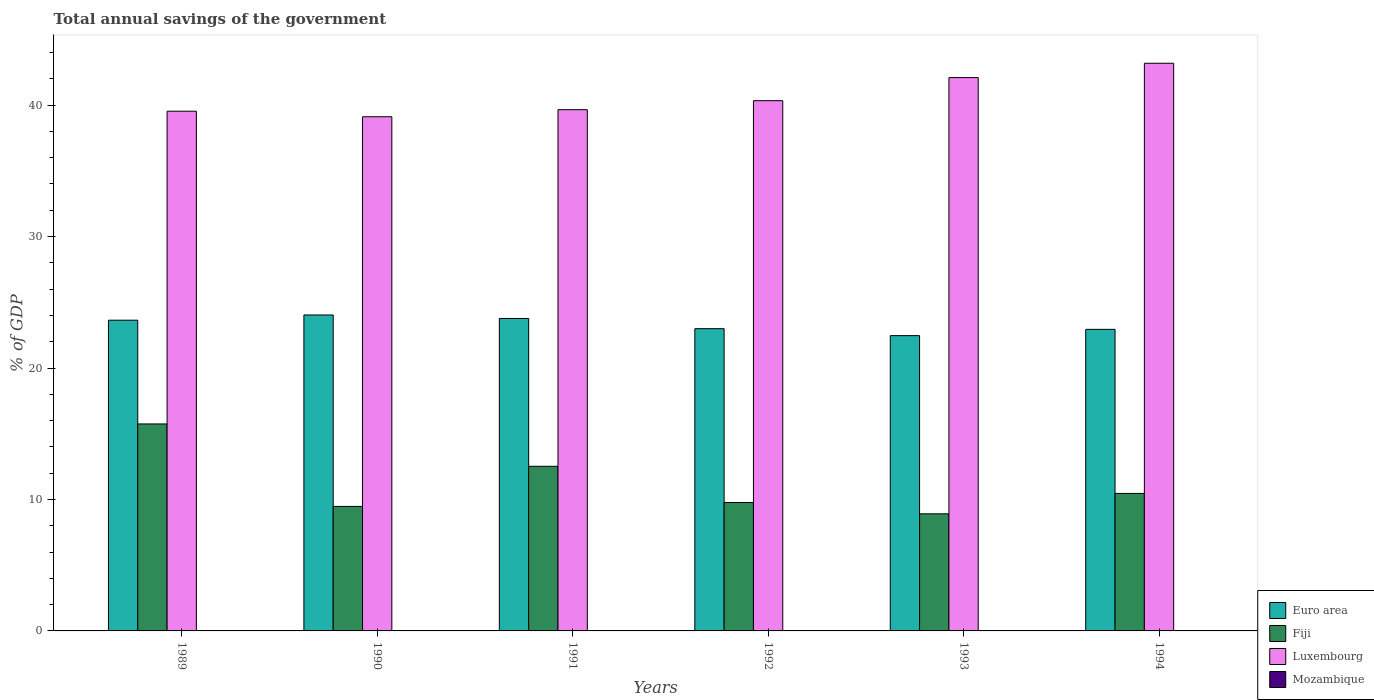Are the number of bars per tick equal to the number of legend labels?
Your answer should be compact. No. Are the number of bars on each tick of the X-axis equal?
Your answer should be compact. Yes. How many bars are there on the 2nd tick from the left?
Give a very brief answer. 3. What is the total annual savings of the government in Euro area in 1990?
Your answer should be very brief. 24.03. Across all years, what is the maximum total annual savings of the government in Euro area?
Your response must be concise. 24.03. Across all years, what is the minimum total annual savings of the government in Euro area?
Offer a very short reply. 22.46. What is the total total annual savings of the government in Euro area in the graph?
Your answer should be compact. 139.83. What is the difference between the total annual savings of the government in Luxembourg in 1993 and that in 1994?
Provide a short and direct response. -1.09. What is the difference between the total annual savings of the government in Fiji in 1992 and the total annual savings of the government in Euro area in 1993?
Provide a succinct answer. -12.69. What is the average total annual savings of the government in Euro area per year?
Keep it short and to the point. 23.31. In the year 1991, what is the difference between the total annual savings of the government in Euro area and total annual savings of the government in Fiji?
Give a very brief answer. 11.25. What is the ratio of the total annual savings of the government in Fiji in 1990 to that in 1991?
Your answer should be very brief. 0.76. Is the total annual savings of the government in Luxembourg in 1989 less than that in 1994?
Your answer should be compact. Yes. Is the difference between the total annual savings of the government in Euro area in 1989 and 1991 greater than the difference between the total annual savings of the government in Fiji in 1989 and 1991?
Make the answer very short. No. What is the difference between the highest and the second highest total annual savings of the government in Euro area?
Make the answer very short. 0.27. What is the difference between the highest and the lowest total annual savings of the government in Euro area?
Offer a terse response. 1.57. In how many years, is the total annual savings of the government in Euro area greater than the average total annual savings of the government in Euro area taken over all years?
Keep it short and to the point. 3. Is it the case that in every year, the sum of the total annual savings of the government in Euro area and total annual savings of the government in Mozambique is greater than the sum of total annual savings of the government in Luxembourg and total annual savings of the government in Fiji?
Keep it short and to the point. No. Is it the case that in every year, the sum of the total annual savings of the government in Fiji and total annual savings of the government in Euro area is greater than the total annual savings of the government in Luxembourg?
Your response must be concise. No. Are all the bars in the graph horizontal?
Offer a terse response. No. How many years are there in the graph?
Offer a terse response. 6. Does the graph contain grids?
Offer a terse response. No. How many legend labels are there?
Provide a succinct answer. 4. What is the title of the graph?
Your answer should be very brief. Total annual savings of the government. Does "St. Kitts and Nevis" appear as one of the legend labels in the graph?
Make the answer very short. No. What is the label or title of the Y-axis?
Keep it short and to the point. % of GDP. What is the % of GDP of Euro area in 1989?
Make the answer very short. 23.64. What is the % of GDP in Fiji in 1989?
Offer a terse response. 15.74. What is the % of GDP in Luxembourg in 1989?
Your response must be concise. 39.53. What is the % of GDP in Mozambique in 1989?
Your response must be concise. 0. What is the % of GDP of Euro area in 1990?
Provide a short and direct response. 24.03. What is the % of GDP in Fiji in 1990?
Provide a succinct answer. 9.47. What is the % of GDP of Luxembourg in 1990?
Give a very brief answer. 39.11. What is the % of GDP of Euro area in 1991?
Your answer should be very brief. 23.77. What is the % of GDP in Fiji in 1991?
Provide a short and direct response. 12.52. What is the % of GDP of Luxembourg in 1991?
Your answer should be compact. 39.65. What is the % of GDP in Euro area in 1992?
Offer a very short reply. 22.99. What is the % of GDP of Fiji in 1992?
Your answer should be compact. 9.77. What is the % of GDP of Luxembourg in 1992?
Provide a succinct answer. 40.33. What is the % of GDP of Mozambique in 1992?
Your answer should be very brief. 0. What is the % of GDP of Euro area in 1993?
Your answer should be very brief. 22.46. What is the % of GDP of Fiji in 1993?
Your response must be concise. 8.91. What is the % of GDP in Luxembourg in 1993?
Make the answer very short. 42.09. What is the % of GDP of Euro area in 1994?
Offer a very short reply. 22.94. What is the % of GDP of Fiji in 1994?
Offer a very short reply. 10.46. What is the % of GDP in Luxembourg in 1994?
Your answer should be compact. 43.18. Across all years, what is the maximum % of GDP of Euro area?
Provide a succinct answer. 24.03. Across all years, what is the maximum % of GDP in Fiji?
Keep it short and to the point. 15.74. Across all years, what is the maximum % of GDP in Luxembourg?
Your answer should be compact. 43.18. Across all years, what is the minimum % of GDP in Euro area?
Give a very brief answer. 22.46. Across all years, what is the minimum % of GDP in Fiji?
Your response must be concise. 8.91. Across all years, what is the minimum % of GDP in Luxembourg?
Offer a very short reply. 39.11. What is the total % of GDP in Euro area in the graph?
Make the answer very short. 139.83. What is the total % of GDP of Fiji in the graph?
Give a very brief answer. 66.87. What is the total % of GDP in Luxembourg in the graph?
Ensure brevity in your answer.  243.91. What is the total % of GDP in Mozambique in the graph?
Make the answer very short. 0. What is the difference between the % of GDP of Euro area in 1989 and that in 1990?
Ensure brevity in your answer.  -0.4. What is the difference between the % of GDP in Fiji in 1989 and that in 1990?
Your answer should be very brief. 6.27. What is the difference between the % of GDP in Luxembourg in 1989 and that in 1990?
Give a very brief answer. 0.42. What is the difference between the % of GDP of Euro area in 1989 and that in 1991?
Give a very brief answer. -0.13. What is the difference between the % of GDP of Fiji in 1989 and that in 1991?
Offer a terse response. 3.22. What is the difference between the % of GDP in Luxembourg in 1989 and that in 1991?
Keep it short and to the point. -0.12. What is the difference between the % of GDP in Euro area in 1989 and that in 1992?
Offer a terse response. 0.65. What is the difference between the % of GDP in Fiji in 1989 and that in 1992?
Ensure brevity in your answer.  5.98. What is the difference between the % of GDP of Luxembourg in 1989 and that in 1992?
Ensure brevity in your answer.  -0.8. What is the difference between the % of GDP in Euro area in 1989 and that in 1993?
Keep it short and to the point. 1.17. What is the difference between the % of GDP of Fiji in 1989 and that in 1993?
Your response must be concise. 6.84. What is the difference between the % of GDP in Luxembourg in 1989 and that in 1993?
Offer a terse response. -2.56. What is the difference between the % of GDP of Euro area in 1989 and that in 1994?
Ensure brevity in your answer.  0.7. What is the difference between the % of GDP of Fiji in 1989 and that in 1994?
Your answer should be compact. 5.29. What is the difference between the % of GDP of Luxembourg in 1989 and that in 1994?
Keep it short and to the point. -3.65. What is the difference between the % of GDP of Euro area in 1990 and that in 1991?
Your answer should be compact. 0.27. What is the difference between the % of GDP in Fiji in 1990 and that in 1991?
Ensure brevity in your answer.  -3.05. What is the difference between the % of GDP of Luxembourg in 1990 and that in 1991?
Make the answer very short. -0.54. What is the difference between the % of GDP of Euro area in 1990 and that in 1992?
Offer a terse response. 1.04. What is the difference between the % of GDP in Fiji in 1990 and that in 1992?
Keep it short and to the point. -0.3. What is the difference between the % of GDP in Luxembourg in 1990 and that in 1992?
Your answer should be compact. -1.22. What is the difference between the % of GDP in Euro area in 1990 and that in 1993?
Offer a very short reply. 1.57. What is the difference between the % of GDP in Fiji in 1990 and that in 1993?
Your answer should be very brief. 0.56. What is the difference between the % of GDP in Luxembourg in 1990 and that in 1993?
Provide a succinct answer. -2.98. What is the difference between the % of GDP of Euro area in 1990 and that in 1994?
Keep it short and to the point. 1.09. What is the difference between the % of GDP of Fiji in 1990 and that in 1994?
Offer a terse response. -0.99. What is the difference between the % of GDP of Luxembourg in 1990 and that in 1994?
Your answer should be compact. -4.07. What is the difference between the % of GDP in Euro area in 1991 and that in 1992?
Ensure brevity in your answer.  0.78. What is the difference between the % of GDP of Fiji in 1991 and that in 1992?
Ensure brevity in your answer.  2.75. What is the difference between the % of GDP in Luxembourg in 1991 and that in 1992?
Offer a very short reply. -0.68. What is the difference between the % of GDP of Euro area in 1991 and that in 1993?
Your answer should be compact. 1.31. What is the difference between the % of GDP in Fiji in 1991 and that in 1993?
Your answer should be compact. 3.61. What is the difference between the % of GDP of Luxembourg in 1991 and that in 1993?
Provide a short and direct response. -2.44. What is the difference between the % of GDP of Euro area in 1991 and that in 1994?
Offer a very short reply. 0.83. What is the difference between the % of GDP of Fiji in 1991 and that in 1994?
Your answer should be very brief. 2.06. What is the difference between the % of GDP of Luxembourg in 1991 and that in 1994?
Your response must be concise. -3.53. What is the difference between the % of GDP in Euro area in 1992 and that in 1993?
Provide a short and direct response. 0.53. What is the difference between the % of GDP of Fiji in 1992 and that in 1993?
Provide a short and direct response. 0.86. What is the difference between the % of GDP in Luxembourg in 1992 and that in 1993?
Ensure brevity in your answer.  -1.76. What is the difference between the % of GDP in Euro area in 1992 and that in 1994?
Offer a very short reply. 0.05. What is the difference between the % of GDP of Fiji in 1992 and that in 1994?
Offer a very short reply. -0.69. What is the difference between the % of GDP of Luxembourg in 1992 and that in 1994?
Your answer should be compact. -2.85. What is the difference between the % of GDP in Euro area in 1993 and that in 1994?
Ensure brevity in your answer.  -0.48. What is the difference between the % of GDP of Fiji in 1993 and that in 1994?
Make the answer very short. -1.55. What is the difference between the % of GDP in Luxembourg in 1993 and that in 1994?
Offer a very short reply. -1.09. What is the difference between the % of GDP of Euro area in 1989 and the % of GDP of Fiji in 1990?
Ensure brevity in your answer.  14.17. What is the difference between the % of GDP of Euro area in 1989 and the % of GDP of Luxembourg in 1990?
Your answer should be very brief. -15.48. What is the difference between the % of GDP in Fiji in 1989 and the % of GDP in Luxembourg in 1990?
Keep it short and to the point. -23.37. What is the difference between the % of GDP in Euro area in 1989 and the % of GDP in Fiji in 1991?
Make the answer very short. 11.11. What is the difference between the % of GDP of Euro area in 1989 and the % of GDP of Luxembourg in 1991?
Provide a succinct answer. -16.01. What is the difference between the % of GDP of Fiji in 1989 and the % of GDP of Luxembourg in 1991?
Your answer should be very brief. -23.91. What is the difference between the % of GDP of Euro area in 1989 and the % of GDP of Fiji in 1992?
Keep it short and to the point. 13.87. What is the difference between the % of GDP of Euro area in 1989 and the % of GDP of Luxembourg in 1992?
Provide a short and direct response. -16.7. What is the difference between the % of GDP of Fiji in 1989 and the % of GDP of Luxembourg in 1992?
Make the answer very short. -24.59. What is the difference between the % of GDP in Euro area in 1989 and the % of GDP in Fiji in 1993?
Offer a terse response. 14.73. What is the difference between the % of GDP of Euro area in 1989 and the % of GDP of Luxembourg in 1993?
Keep it short and to the point. -18.45. What is the difference between the % of GDP of Fiji in 1989 and the % of GDP of Luxembourg in 1993?
Make the answer very short. -26.35. What is the difference between the % of GDP of Euro area in 1989 and the % of GDP of Fiji in 1994?
Offer a very short reply. 13.18. What is the difference between the % of GDP of Euro area in 1989 and the % of GDP of Luxembourg in 1994?
Your response must be concise. -19.54. What is the difference between the % of GDP of Fiji in 1989 and the % of GDP of Luxembourg in 1994?
Your answer should be compact. -27.44. What is the difference between the % of GDP of Euro area in 1990 and the % of GDP of Fiji in 1991?
Keep it short and to the point. 11.51. What is the difference between the % of GDP in Euro area in 1990 and the % of GDP in Luxembourg in 1991?
Your answer should be very brief. -15.62. What is the difference between the % of GDP in Fiji in 1990 and the % of GDP in Luxembourg in 1991?
Your answer should be compact. -30.18. What is the difference between the % of GDP of Euro area in 1990 and the % of GDP of Fiji in 1992?
Keep it short and to the point. 14.27. What is the difference between the % of GDP of Euro area in 1990 and the % of GDP of Luxembourg in 1992?
Offer a very short reply. -16.3. What is the difference between the % of GDP in Fiji in 1990 and the % of GDP in Luxembourg in 1992?
Provide a short and direct response. -30.86. What is the difference between the % of GDP of Euro area in 1990 and the % of GDP of Fiji in 1993?
Your answer should be very brief. 15.13. What is the difference between the % of GDP of Euro area in 1990 and the % of GDP of Luxembourg in 1993?
Your response must be concise. -18.06. What is the difference between the % of GDP in Fiji in 1990 and the % of GDP in Luxembourg in 1993?
Make the answer very short. -32.62. What is the difference between the % of GDP of Euro area in 1990 and the % of GDP of Fiji in 1994?
Keep it short and to the point. 13.58. What is the difference between the % of GDP of Euro area in 1990 and the % of GDP of Luxembourg in 1994?
Keep it short and to the point. -19.15. What is the difference between the % of GDP of Fiji in 1990 and the % of GDP of Luxembourg in 1994?
Your response must be concise. -33.71. What is the difference between the % of GDP of Euro area in 1991 and the % of GDP of Fiji in 1992?
Your answer should be very brief. 14. What is the difference between the % of GDP of Euro area in 1991 and the % of GDP of Luxembourg in 1992?
Make the answer very short. -16.57. What is the difference between the % of GDP in Fiji in 1991 and the % of GDP in Luxembourg in 1992?
Make the answer very short. -27.81. What is the difference between the % of GDP of Euro area in 1991 and the % of GDP of Fiji in 1993?
Keep it short and to the point. 14.86. What is the difference between the % of GDP of Euro area in 1991 and the % of GDP of Luxembourg in 1993?
Your answer should be compact. -18.32. What is the difference between the % of GDP in Fiji in 1991 and the % of GDP in Luxembourg in 1993?
Make the answer very short. -29.57. What is the difference between the % of GDP of Euro area in 1991 and the % of GDP of Fiji in 1994?
Ensure brevity in your answer.  13.31. What is the difference between the % of GDP of Euro area in 1991 and the % of GDP of Luxembourg in 1994?
Your response must be concise. -19.41. What is the difference between the % of GDP of Fiji in 1991 and the % of GDP of Luxembourg in 1994?
Your answer should be very brief. -30.66. What is the difference between the % of GDP in Euro area in 1992 and the % of GDP in Fiji in 1993?
Ensure brevity in your answer.  14.08. What is the difference between the % of GDP in Euro area in 1992 and the % of GDP in Luxembourg in 1993?
Give a very brief answer. -19.1. What is the difference between the % of GDP in Fiji in 1992 and the % of GDP in Luxembourg in 1993?
Give a very brief answer. -32.32. What is the difference between the % of GDP of Euro area in 1992 and the % of GDP of Fiji in 1994?
Ensure brevity in your answer.  12.53. What is the difference between the % of GDP in Euro area in 1992 and the % of GDP in Luxembourg in 1994?
Provide a short and direct response. -20.19. What is the difference between the % of GDP in Fiji in 1992 and the % of GDP in Luxembourg in 1994?
Your answer should be very brief. -33.41. What is the difference between the % of GDP of Euro area in 1993 and the % of GDP of Fiji in 1994?
Provide a succinct answer. 12. What is the difference between the % of GDP in Euro area in 1993 and the % of GDP in Luxembourg in 1994?
Your answer should be compact. -20.72. What is the difference between the % of GDP in Fiji in 1993 and the % of GDP in Luxembourg in 1994?
Offer a terse response. -34.27. What is the average % of GDP in Euro area per year?
Keep it short and to the point. 23.31. What is the average % of GDP in Fiji per year?
Make the answer very short. 11.15. What is the average % of GDP in Luxembourg per year?
Offer a very short reply. 40.65. What is the average % of GDP in Mozambique per year?
Your answer should be very brief. 0. In the year 1989, what is the difference between the % of GDP of Euro area and % of GDP of Fiji?
Make the answer very short. 7.89. In the year 1989, what is the difference between the % of GDP in Euro area and % of GDP in Luxembourg?
Your answer should be compact. -15.9. In the year 1989, what is the difference between the % of GDP of Fiji and % of GDP of Luxembourg?
Offer a terse response. -23.79. In the year 1990, what is the difference between the % of GDP of Euro area and % of GDP of Fiji?
Give a very brief answer. 14.56. In the year 1990, what is the difference between the % of GDP in Euro area and % of GDP in Luxembourg?
Keep it short and to the point. -15.08. In the year 1990, what is the difference between the % of GDP of Fiji and % of GDP of Luxembourg?
Offer a very short reply. -29.64. In the year 1991, what is the difference between the % of GDP of Euro area and % of GDP of Fiji?
Your answer should be very brief. 11.25. In the year 1991, what is the difference between the % of GDP in Euro area and % of GDP in Luxembourg?
Provide a short and direct response. -15.88. In the year 1991, what is the difference between the % of GDP in Fiji and % of GDP in Luxembourg?
Provide a succinct answer. -27.13. In the year 1992, what is the difference between the % of GDP of Euro area and % of GDP of Fiji?
Your answer should be very brief. 13.22. In the year 1992, what is the difference between the % of GDP in Euro area and % of GDP in Luxembourg?
Provide a short and direct response. -17.34. In the year 1992, what is the difference between the % of GDP in Fiji and % of GDP in Luxembourg?
Your response must be concise. -30.57. In the year 1993, what is the difference between the % of GDP of Euro area and % of GDP of Fiji?
Offer a very short reply. 13.56. In the year 1993, what is the difference between the % of GDP in Euro area and % of GDP in Luxembourg?
Offer a terse response. -19.63. In the year 1993, what is the difference between the % of GDP in Fiji and % of GDP in Luxembourg?
Provide a short and direct response. -33.18. In the year 1994, what is the difference between the % of GDP in Euro area and % of GDP in Fiji?
Provide a succinct answer. 12.48. In the year 1994, what is the difference between the % of GDP in Euro area and % of GDP in Luxembourg?
Give a very brief answer. -20.24. In the year 1994, what is the difference between the % of GDP in Fiji and % of GDP in Luxembourg?
Provide a succinct answer. -32.72. What is the ratio of the % of GDP of Euro area in 1989 to that in 1990?
Provide a succinct answer. 0.98. What is the ratio of the % of GDP of Fiji in 1989 to that in 1990?
Make the answer very short. 1.66. What is the ratio of the % of GDP in Luxembourg in 1989 to that in 1990?
Your answer should be very brief. 1.01. What is the ratio of the % of GDP of Fiji in 1989 to that in 1991?
Your answer should be compact. 1.26. What is the ratio of the % of GDP in Luxembourg in 1989 to that in 1991?
Your answer should be very brief. 1. What is the ratio of the % of GDP in Euro area in 1989 to that in 1992?
Give a very brief answer. 1.03. What is the ratio of the % of GDP in Fiji in 1989 to that in 1992?
Your answer should be very brief. 1.61. What is the ratio of the % of GDP in Luxembourg in 1989 to that in 1992?
Give a very brief answer. 0.98. What is the ratio of the % of GDP of Euro area in 1989 to that in 1993?
Give a very brief answer. 1.05. What is the ratio of the % of GDP in Fiji in 1989 to that in 1993?
Provide a short and direct response. 1.77. What is the ratio of the % of GDP in Luxembourg in 1989 to that in 1993?
Keep it short and to the point. 0.94. What is the ratio of the % of GDP of Euro area in 1989 to that in 1994?
Ensure brevity in your answer.  1.03. What is the ratio of the % of GDP of Fiji in 1989 to that in 1994?
Make the answer very short. 1.51. What is the ratio of the % of GDP of Luxembourg in 1989 to that in 1994?
Your answer should be very brief. 0.92. What is the ratio of the % of GDP in Euro area in 1990 to that in 1991?
Your answer should be very brief. 1.01. What is the ratio of the % of GDP of Fiji in 1990 to that in 1991?
Make the answer very short. 0.76. What is the ratio of the % of GDP in Luxembourg in 1990 to that in 1991?
Make the answer very short. 0.99. What is the ratio of the % of GDP of Euro area in 1990 to that in 1992?
Offer a terse response. 1.05. What is the ratio of the % of GDP of Fiji in 1990 to that in 1992?
Provide a short and direct response. 0.97. What is the ratio of the % of GDP of Luxembourg in 1990 to that in 1992?
Offer a very short reply. 0.97. What is the ratio of the % of GDP of Euro area in 1990 to that in 1993?
Offer a very short reply. 1.07. What is the ratio of the % of GDP in Fiji in 1990 to that in 1993?
Provide a succinct answer. 1.06. What is the ratio of the % of GDP in Luxembourg in 1990 to that in 1993?
Give a very brief answer. 0.93. What is the ratio of the % of GDP in Euro area in 1990 to that in 1994?
Offer a terse response. 1.05. What is the ratio of the % of GDP in Fiji in 1990 to that in 1994?
Give a very brief answer. 0.91. What is the ratio of the % of GDP in Luxembourg in 1990 to that in 1994?
Make the answer very short. 0.91. What is the ratio of the % of GDP in Euro area in 1991 to that in 1992?
Ensure brevity in your answer.  1.03. What is the ratio of the % of GDP of Fiji in 1991 to that in 1992?
Your answer should be very brief. 1.28. What is the ratio of the % of GDP of Luxembourg in 1991 to that in 1992?
Your answer should be very brief. 0.98. What is the ratio of the % of GDP of Euro area in 1991 to that in 1993?
Give a very brief answer. 1.06. What is the ratio of the % of GDP of Fiji in 1991 to that in 1993?
Make the answer very short. 1.41. What is the ratio of the % of GDP in Luxembourg in 1991 to that in 1993?
Your answer should be compact. 0.94. What is the ratio of the % of GDP of Euro area in 1991 to that in 1994?
Make the answer very short. 1.04. What is the ratio of the % of GDP in Fiji in 1991 to that in 1994?
Make the answer very short. 1.2. What is the ratio of the % of GDP in Luxembourg in 1991 to that in 1994?
Keep it short and to the point. 0.92. What is the ratio of the % of GDP in Euro area in 1992 to that in 1993?
Give a very brief answer. 1.02. What is the ratio of the % of GDP of Fiji in 1992 to that in 1993?
Your response must be concise. 1.1. What is the ratio of the % of GDP in Fiji in 1992 to that in 1994?
Your response must be concise. 0.93. What is the ratio of the % of GDP in Luxembourg in 1992 to that in 1994?
Keep it short and to the point. 0.93. What is the ratio of the % of GDP in Euro area in 1993 to that in 1994?
Make the answer very short. 0.98. What is the ratio of the % of GDP in Fiji in 1993 to that in 1994?
Your answer should be very brief. 0.85. What is the ratio of the % of GDP of Luxembourg in 1993 to that in 1994?
Give a very brief answer. 0.97. What is the difference between the highest and the second highest % of GDP in Euro area?
Keep it short and to the point. 0.27. What is the difference between the highest and the second highest % of GDP in Fiji?
Your response must be concise. 3.22. What is the difference between the highest and the second highest % of GDP of Luxembourg?
Your response must be concise. 1.09. What is the difference between the highest and the lowest % of GDP of Euro area?
Give a very brief answer. 1.57. What is the difference between the highest and the lowest % of GDP of Fiji?
Your answer should be compact. 6.84. What is the difference between the highest and the lowest % of GDP of Luxembourg?
Offer a terse response. 4.07. 